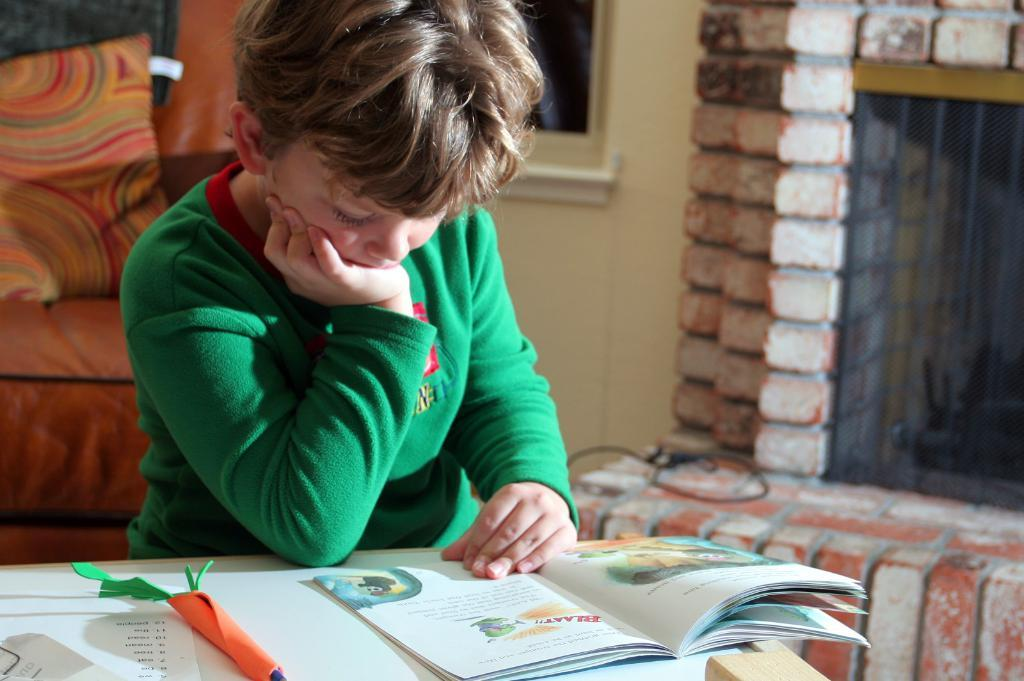<image>
Write a terse but informative summary of the picture. A child reading a book, the word "Blaaat!" can be seen on the page. 